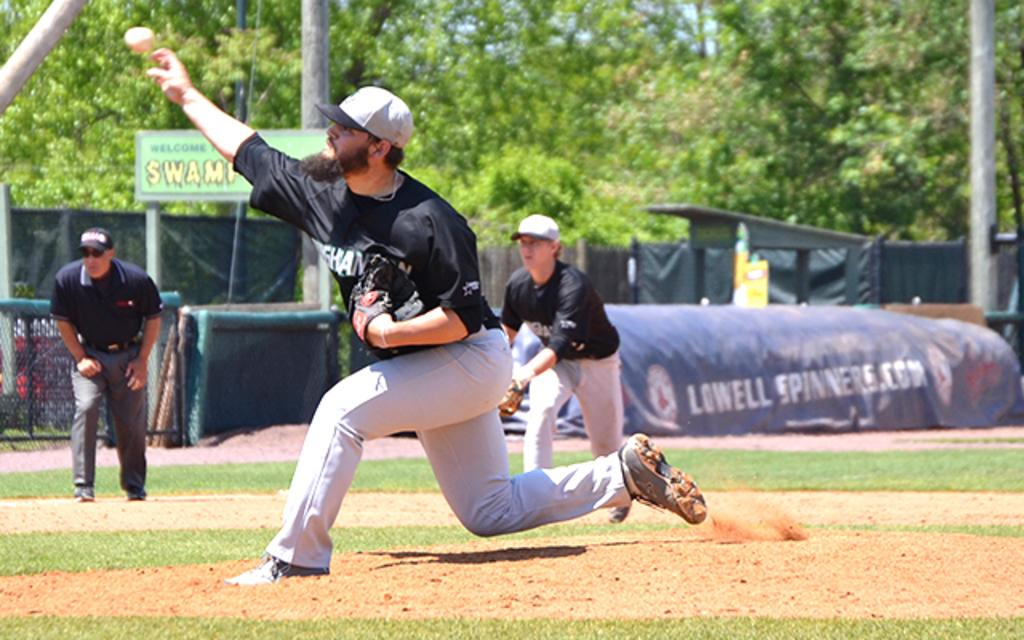Provide a one-sentence caption for the provided image. The ad on the field covering is for Lowell Soinners.com. 